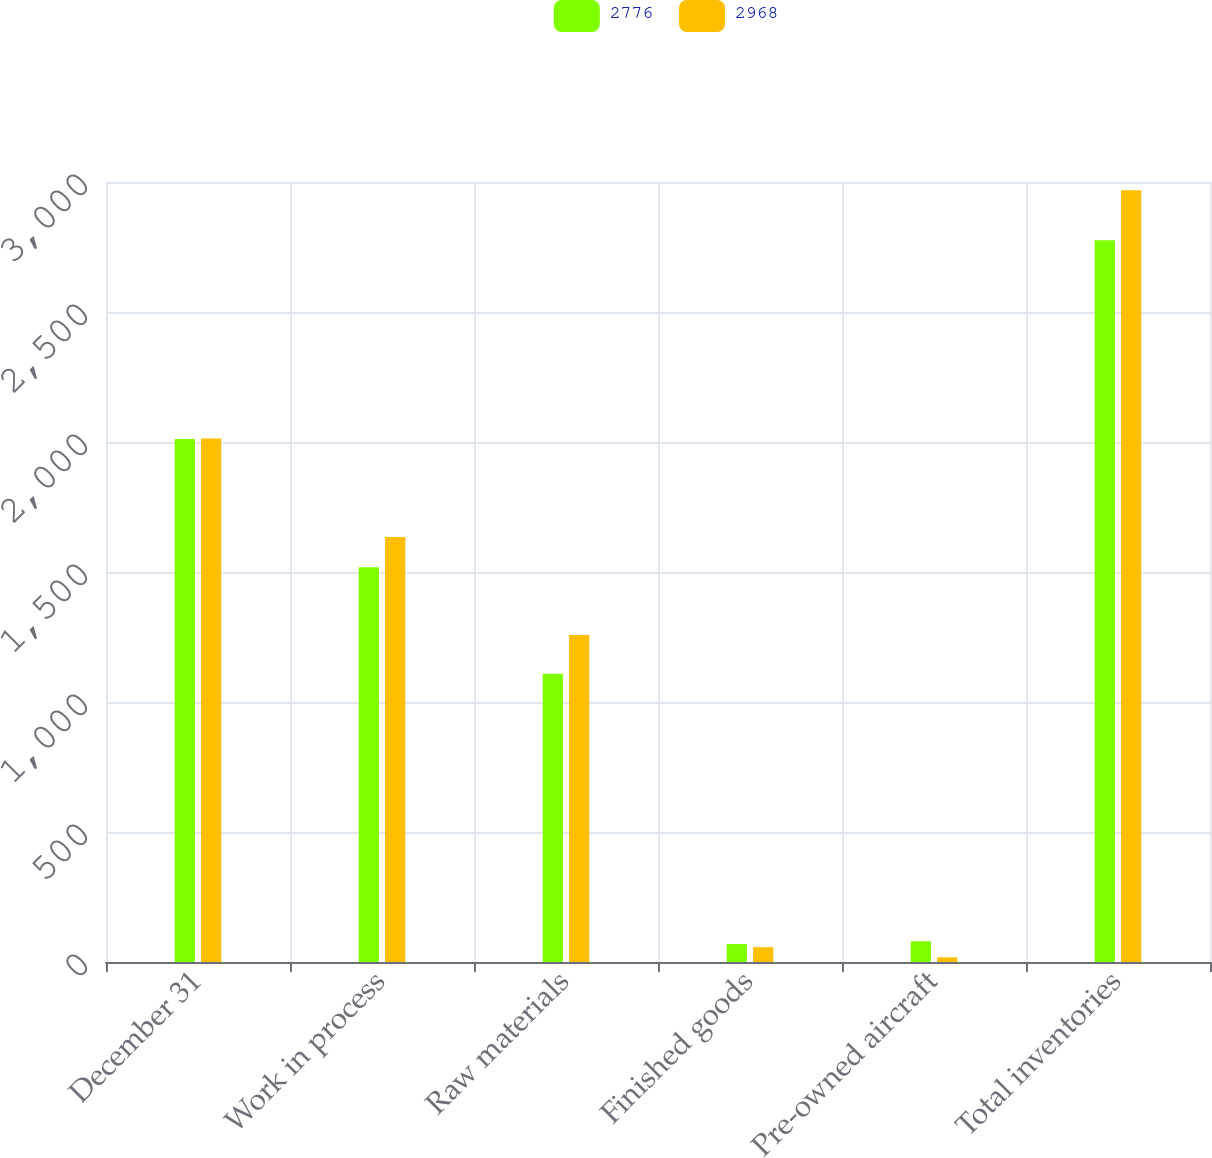Convert chart to OTSL. <chart><loc_0><loc_0><loc_500><loc_500><stacked_bar_chart><ecel><fcel>December 31<fcel>Work in process<fcel>Raw materials<fcel>Finished goods<fcel>Pre-owned aircraft<fcel>Total inventories<nl><fcel>2776<fcel>2012<fcel>1518<fcel>1109<fcel>69<fcel>80<fcel>2776<nl><fcel>2968<fcel>2013<fcel>1635<fcel>1258<fcel>57<fcel>18<fcel>2968<nl></chart> 